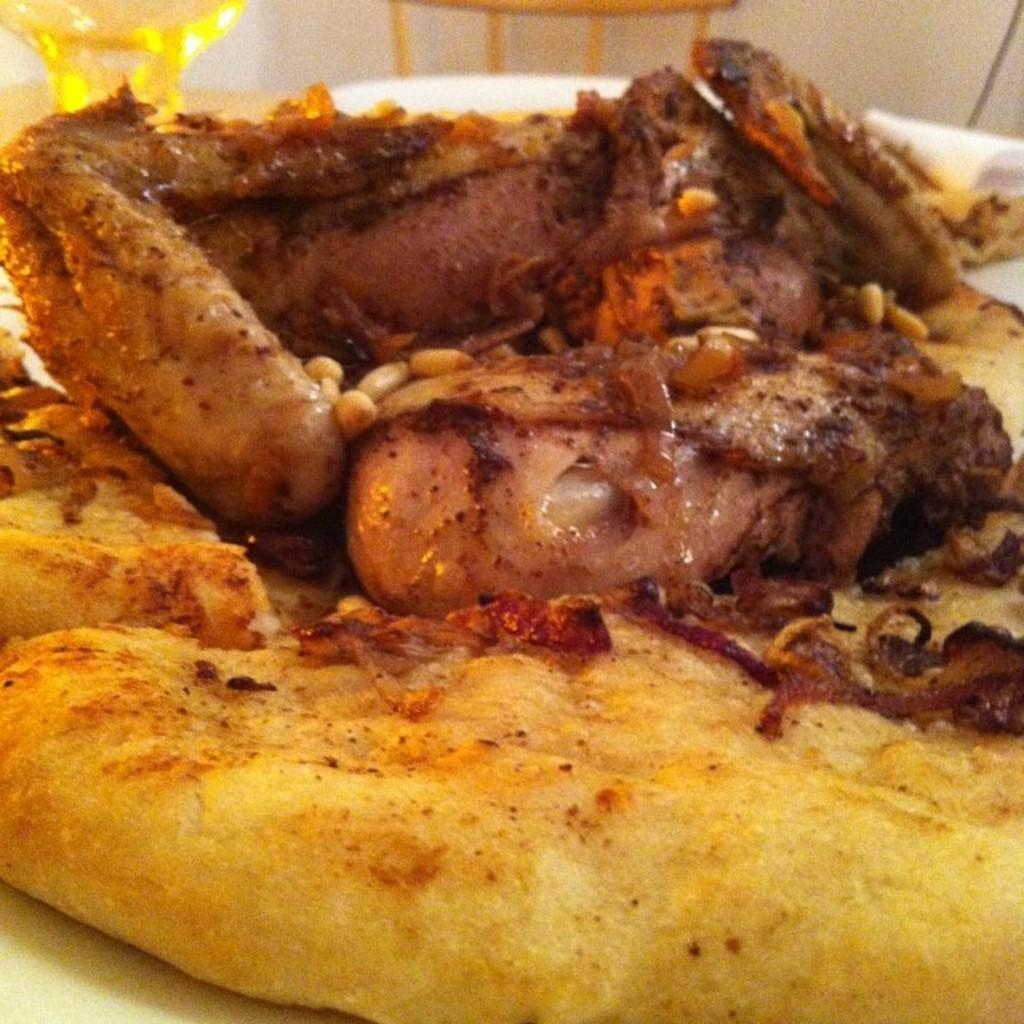Describe this image in one or two sentences. In this image, we can see eatable things are placed on the white surface. Top of the image, we can see glass, some object and white color. 